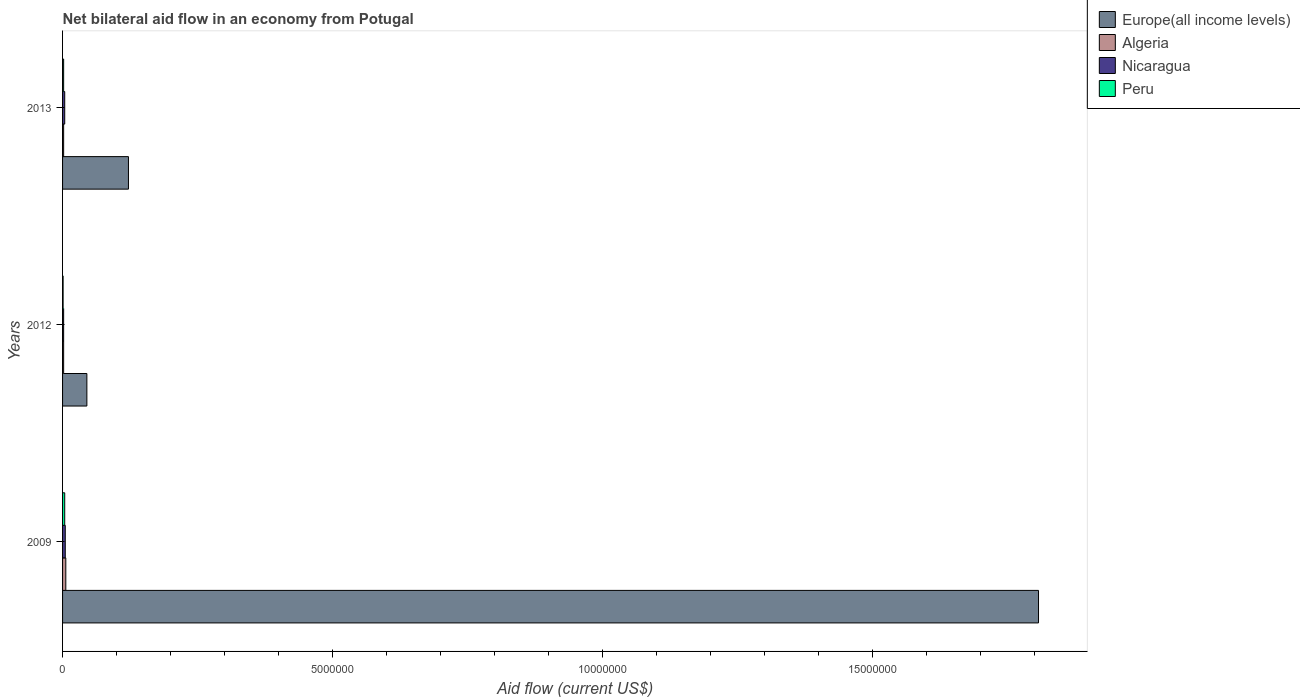How many bars are there on the 2nd tick from the top?
Provide a succinct answer. 4. What is the label of the 3rd group of bars from the top?
Give a very brief answer. 2009. Across all years, what is the minimum net bilateral aid flow in Europe(all income levels)?
Give a very brief answer. 4.50e+05. What is the total net bilateral aid flow in Nicaragua in the graph?
Keep it short and to the point. 1.10e+05. What is the difference between the net bilateral aid flow in Europe(all income levels) in 2013 and the net bilateral aid flow in Peru in 2012?
Give a very brief answer. 1.21e+06. What is the average net bilateral aid flow in Nicaragua per year?
Ensure brevity in your answer.  3.67e+04. In how many years, is the net bilateral aid flow in Nicaragua greater than 16000000 US$?
Your answer should be very brief. 0. Is the difference between the net bilateral aid flow in Europe(all income levels) in 2012 and 2013 greater than the difference between the net bilateral aid flow in Nicaragua in 2012 and 2013?
Your answer should be compact. No. What is the difference between the highest and the second highest net bilateral aid flow in Nicaragua?
Make the answer very short. 10000. In how many years, is the net bilateral aid flow in Algeria greater than the average net bilateral aid flow in Algeria taken over all years?
Your answer should be very brief. 1. Is the sum of the net bilateral aid flow in Europe(all income levels) in 2009 and 2013 greater than the maximum net bilateral aid flow in Peru across all years?
Provide a short and direct response. Yes. Is it the case that in every year, the sum of the net bilateral aid flow in Nicaragua and net bilateral aid flow in Peru is greater than the sum of net bilateral aid flow in Algeria and net bilateral aid flow in Europe(all income levels)?
Make the answer very short. No. What does the 4th bar from the top in 2009 represents?
Your answer should be compact. Europe(all income levels). What does the 3rd bar from the bottom in 2013 represents?
Offer a very short reply. Nicaragua. Is it the case that in every year, the sum of the net bilateral aid flow in Europe(all income levels) and net bilateral aid flow in Algeria is greater than the net bilateral aid flow in Peru?
Provide a short and direct response. Yes. How many bars are there?
Offer a very short reply. 12. Are all the bars in the graph horizontal?
Offer a terse response. Yes. How many years are there in the graph?
Provide a succinct answer. 3. What is the difference between two consecutive major ticks on the X-axis?
Your answer should be very brief. 5.00e+06. Are the values on the major ticks of X-axis written in scientific E-notation?
Offer a very short reply. No. Does the graph contain any zero values?
Keep it short and to the point. No. Does the graph contain grids?
Give a very brief answer. No. How are the legend labels stacked?
Provide a short and direct response. Vertical. What is the title of the graph?
Your answer should be very brief. Net bilateral aid flow in an economy from Potugal. Does "Lao PDR" appear as one of the legend labels in the graph?
Offer a very short reply. No. What is the label or title of the Y-axis?
Your answer should be very brief. Years. What is the Aid flow (current US$) in Europe(all income levels) in 2009?
Provide a succinct answer. 1.81e+07. What is the Aid flow (current US$) of Algeria in 2012?
Your response must be concise. 2.00e+04. What is the Aid flow (current US$) of Peru in 2012?
Your response must be concise. 10000. What is the Aid flow (current US$) in Europe(all income levels) in 2013?
Provide a short and direct response. 1.22e+06. What is the Aid flow (current US$) in Algeria in 2013?
Offer a very short reply. 2.00e+04. What is the Aid flow (current US$) of Nicaragua in 2013?
Your response must be concise. 4.00e+04. Across all years, what is the maximum Aid flow (current US$) of Europe(all income levels)?
Your answer should be compact. 1.81e+07. Across all years, what is the maximum Aid flow (current US$) in Algeria?
Provide a succinct answer. 6.00e+04. Across all years, what is the maximum Aid flow (current US$) in Peru?
Offer a terse response. 4.00e+04. Across all years, what is the minimum Aid flow (current US$) in Algeria?
Ensure brevity in your answer.  2.00e+04. Across all years, what is the minimum Aid flow (current US$) of Peru?
Provide a succinct answer. 10000. What is the total Aid flow (current US$) in Europe(all income levels) in the graph?
Make the answer very short. 1.97e+07. What is the total Aid flow (current US$) of Algeria in the graph?
Your answer should be very brief. 1.00e+05. What is the total Aid flow (current US$) in Nicaragua in the graph?
Offer a very short reply. 1.10e+05. What is the difference between the Aid flow (current US$) in Europe(all income levels) in 2009 and that in 2012?
Provide a short and direct response. 1.76e+07. What is the difference between the Aid flow (current US$) in Nicaragua in 2009 and that in 2012?
Ensure brevity in your answer.  3.00e+04. What is the difference between the Aid flow (current US$) of Peru in 2009 and that in 2012?
Keep it short and to the point. 3.00e+04. What is the difference between the Aid flow (current US$) of Europe(all income levels) in 2009 and that in 2013?
Give a very brief answer. 1.68e+07. What is the difference between the Aid flow (current US$) in Algeria in 2009 and that in 2013?
Your response must be concise. 4.00e+04. What is the difference between the Aid flow (current US$) of Europe(all income levels) in 2012 and that in 2013?
Offer a very short reply. -7.70e+05. What is the difference between the Aid flow (current US$) of Nicaragua in 2012 and that in 2013?
Your answer should be compact. -2.00e+04. What is the difference between the Aid flow (current US$) of Europe(all income levels) in 2009 and the Aid flow (current US$) of Algeria in 2012?
Make the answer very short. 1.80e+07. What is the difference between the Aid flow (current US$) in Europe(all income levels) in 2009 and the Aid flow (current US$) in Nicaragua in 2012?
Your answer should be compact. 1.80e+07. What is the difference between the Aid flow (current US$) in Europe(all income levels) in 2009 and the Aid flow (current US$) in Peru in 2012?
Ensure brevity in your answer.  1.81e+07. What is the difference between the Aid flow (current US$) in Algeria in 2009 and the Aid flow (current US$) in Nicaragua in 2012?
Keep it short and to the point. 4.00e+04. What is the difference between the Aid flow (current US$) in Europe(all income levels) in 2009 and the Aid flow (current US$) in Algeria in 2013?
Make the answer very short. 1.80e+07. What is the difference between the Aid flow (current US$) of Europe(all income levels) in 2009 and the Aid flow (current US$) of Nicaragua in 2013?
Give a very brief answer. 1.80e+07. What is the difference between the Aid flow (current US$) of Europe(all income levels) in 2009 and the Aid flow (current US$) of Peru in 2013?
Provide a short and direct response. 1.80e+07. What is the difference between the Aid flow (current US$) of Algeria in 2009 and the Aid flow (current US$) of Nicaragua in 2013?
Offer a terse response. 2.00e+04. What is the difference between the Aid flow (current US$) in Europe(all income levels) in 2012 and the Aid flow (current US$) in Peru in 2013?
Make the answer very short. 4.30e+05. What is the difference between the Aid flow (current US$) of Algeria in 2012 and the Aid flow (current US$) of Nicaragua in 2013?
Your answer should be very brief. -2.00e+04. What is the difference between the Aid flow (current US$) in Algeria in 2012 and the Aid flow (current US$) in Peru in 2013?
Provide a short and direct response. 0. What is the difference between the Aid flow (current US$) of Nicaragua in 2012 and the Aid flow (current US$) of Peru in 2013?
Provide a succinct answer. 0. What is the average Aid flow (current US$) in Europe(all income levels) per year?
Keep it short and to the point. 6.58e+06. What is the average Aid flow (current US$) of Algeria per year?
Offer a terse response. 3.33e+04. What is the average Aid flow (current US$) of Nicaragua per year?
Give a very brief answer. 3.67e+04. What is the average Aid flow (current US$) in Peru per year?
Provide a short and direct response. 2.33e+04. In the year 2009, what is the difference between the Aid flow (current US$) in Europe(all income levels) and Aid flow (current US$) in Algeria?
Offer a terse response. 1.80e+07. In the year 2009, what is the difference between the Aid flow (current US$) in Europe(all income levels) and Aid flow (current US$) in Nicaragua?
Your answer should be compact. 1.80e+07. In the year 2009, what is the difference between the Aid flow (current US$) of Europe(all income levels) and Aid flow (current US$) of Peru?
Offer a very short reply. 1.80e+07. In the year 2009, what is the difference between the Aid flow (current US$) of Algeria and Aid flow (current US$) of Nicaragua?
Make the answer very short. 10000. In the year 2012, what is the difference between the Aid flow (current US$) in Europe(all income levels) and Aid flow (current US$) in Peru?
Make the answer very short. 4.40e+05. In the year 2012, what is the difference between the Aid flow (current US$) of Algeria and Aid flow (current US$) of Nicaragua?
Your response must be concise. 0. In the year 2012, what is the difference between the Aid flow (current US$) of Algeria and Aid flow (current US$) of Peru?
Keep it short and to the point. 10000. In the year 2013, what is the difference between the Aid flow (current US$) of Europe(all income levels) and Aid flow (current US$) of Algeria?
Keep it short and to the point. 1.20e+06. In the year 2013, what is the difference between the Aid flow (current US$) in Europe(all income levels) and Aid flow (current US$) in Nicaragua?
Provide a succinct answer. 1.18e+06. In the year 2013, what is the difference between the Aid flow (current US$) in Europe(all income levels) and Aid flow (current US$) in Peru?
Offer a very short reply. 1.20e+06. In the year 2013, what is the difference between the Aid flow (current US$) of Algeria and Aid flow (current US$) of Nicaragua?
Offer a terse response. -2.00e+04. In the year 2013, what is the difference between the Aid flow (current US$) in Nicaragua and Aid flow (current US$) in Peru?
Keep it short and to the point. 2.00e+04. What is the ratio of the Aid flow (current US$) of Europe(all income levels) in 2009 to that in 2012?
Your answer should be compact. 40.16. What is the ratio of the Aid flow (current US$) of Algeria in 2009 to that in 2012?
Your answer should be very brief. 3. What is the ratio of the Aid flow (current US$) in Peru in 2009 to that in 2012?
Provide a succinct answer. 4. What is the ratio of the Aid flow (current US$) in Europe(all income levels) in 2009 to that in 2013?
Provide a succinct answer. 14.81. What is the ratio of the Aid flow (current US$) of Algeria in 2009 to that in 2013?
Keep it short and to the point. 3. What is the ratio of the Aid flow (current US$) in Nicaragua in 2009 to that in 2013?
Your answer should be very brief. 1.25. What is the ratio of the Aid flow (current US$) in Europe(all income levels) in 2012 to that in 2013?
Ensure brevity in your answer.  0.37. What is the ratio of the Aid flow (current US$) of Algeria in 2012 to that in 2013?
Offer a terse response. 1. What is the difference between the highest and the second highest Aid flow (current US$) in Europe(all income levels)?
Offer a terse response. 1.68e+07. What is the difference between the highest and the second highest Aid flow (current US$) in Peru?
Keep it short and to the point. 2.00e+04. What is the difference between the highest and the lowest Aid flow (current US$) of Europe(all income levels)?
Offer a terse response. 1.76e+07. What is the difference between the highest and the lowest Aid flow (current US$) in Nicaragua?
Make the answer very short. 3.00e+04. 